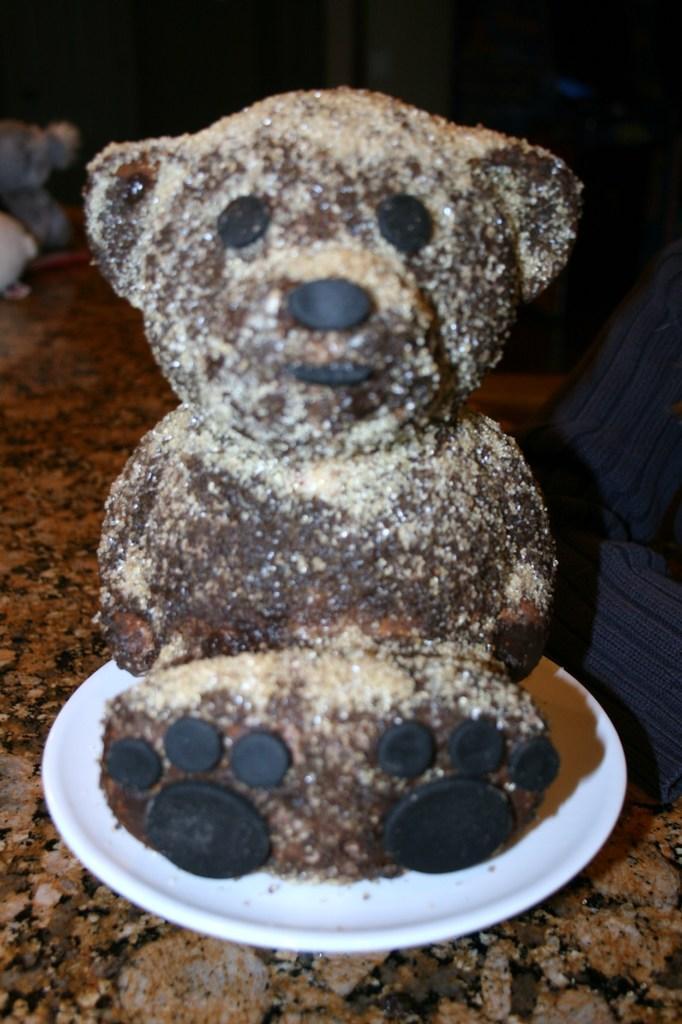Describe this image in one or two sentences. In this image we can see a plate containing a chocolate in the shape of a teddy bear. On the right there is a person's hand. At the bottom there is a floor. 